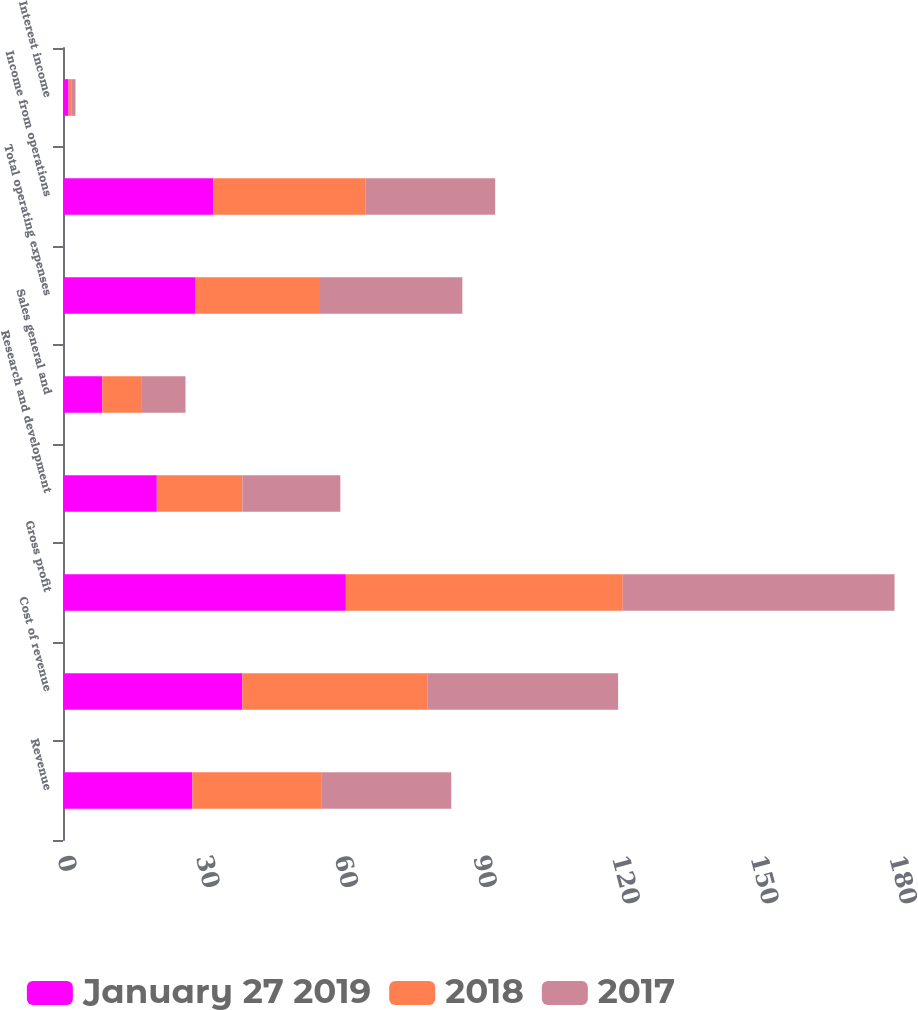<chart> <loc_0><loc_0><loc_500><loc_500><stacked_bar_chart><ecel><fcel>Revenue<fcel>Cost of revenue<fcel>Gross profit<fcel>Research and development<fcel>Sales general and<fcel>Total operating expenses<fcel>Income from operations<fcel>Interest income<nl><fcel>January 27 2019<fcel>28<fcel>38.8<fcel>61.2<fcel>20.3<fcel>8.5<fcel>28.7<fcel>32.5<fcel>1.2<nl><fcel>2018<fcel>28<fcel>40.1<fcel>59.9<fcel>18.5<fcel>8.4<fcel>26.9<fcel>33<fcel>0.7<nl><fcel>2017<fcel>28<fcel>41.2<fcel>58.8<fcel>21.2<fcel>9.6<fcel>30.8<fcel>28<fcel>0.8<nl></chart> 